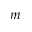<formula> <loc_0><loc_0><loc_500><loc_500>m</formula> 